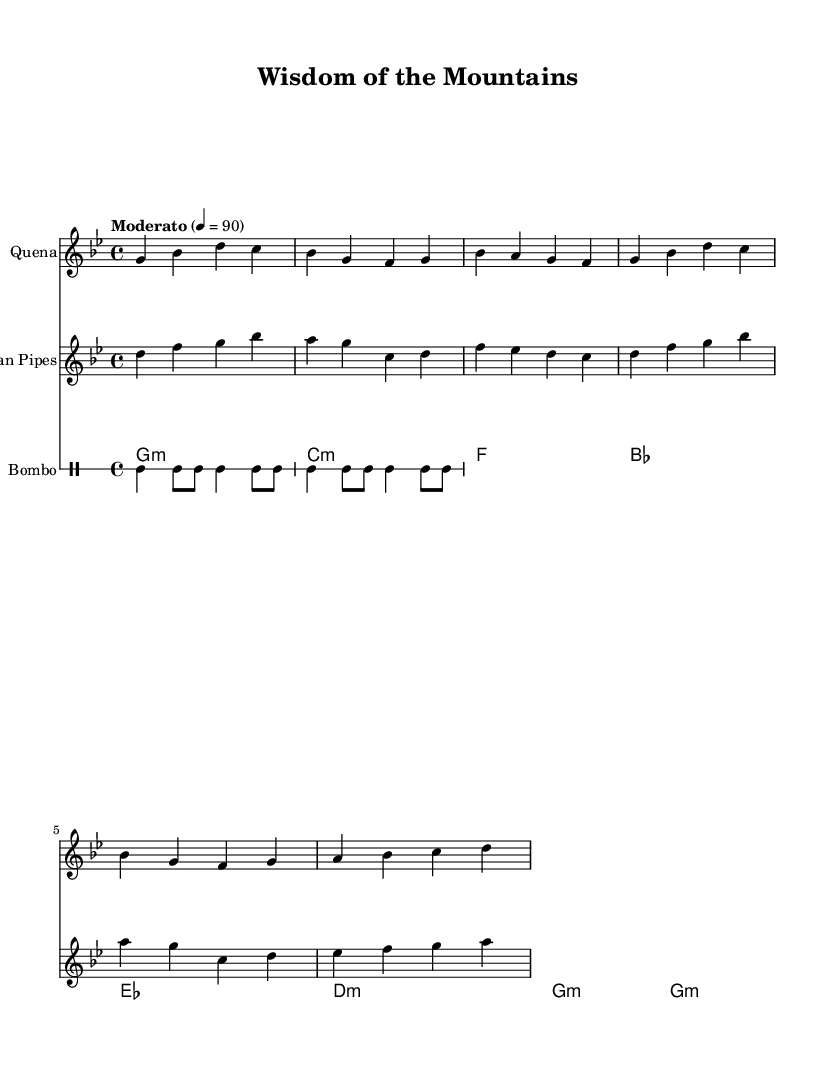What is the key signature of this music? The key signature indicated at the beginning of the score shows two flats, which corresponds to G minor.
Answer: G minor What is the time signature of this music? The time signature placed at the beginning of the score shows a 4 over 4, indicating four beats in each measure.
Answer: 4/4 What is the tempo marking for this piece? The tempo instruction provided states "Moderato" with a metronome marking of 90 beats per minute, suggesting a moderate pace.
Answer: Moderato, 90 How many different instruments are featured in this music? The score displays four distinct parts: Quena, Pan Pipes, Charango, and Bombo, indicating that four different instruments are used.
Answer: Four What is the rhythmic pattern used by the Bombo? The Bombo part combines bass drum hits and snare hits, repeated with two bass notes followed by two snare notes in each measure.
Answer: Bass and snare pattern Which instrument plays the highest melody in this score? By comparing the notes written for each instrument, the Quena part contains the highest pitches among all the instruments shown.
Answer: Quena What traditional Andean element does this music represent? The music emphasizes indigenous knowledge and sustainable practices, which is a hallmark of and celebration of Andean folk music traditions.
Answer: Indigenous knowledge and sustainable practices 